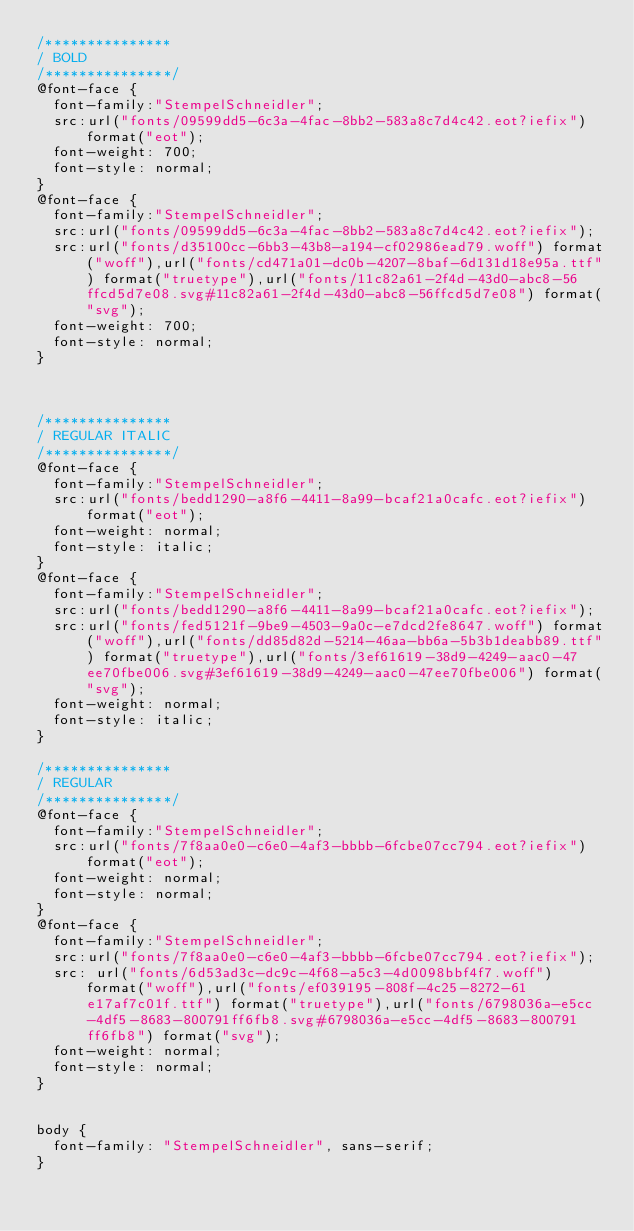Convert code to text. <code><loc_0><loc_0><loc_500><loc_500><_CSS_>/***************
/ BOLD
/***************/
@font-face {
  font-family:"StempelSchneidler";
  src:url("fonts/09599dd5-6c3a-4fac-8bb2-583a8c7d4c42.eot?iefix") format("eot");
  font-weight: 700;
  font-style: normal;
}
@font-face {
  font-family:"StempelSchneidler";
  src:url("fonts/09599dd5-6c3a-4fac-8bb2-583a8c7d4c42.eot?iefix");
  src:url("fonts/d35100cc-6bb3-43b8-a194-cf02986ead79.woff") format("woff"),url("fonts/cd471a01-dc0b-4207-8baf-6d131d18e95a.ttf") format("truetype"),url("fonts/11c82a61-2f4d-43d0-abc8-56ffcd5d7e08.svg#11c82a61-2f4d-43d0-abc8-56ffcd5d7e08") format("svg");
  font-weight: 700;
  font-style: normal;
}



/***************
/ REGULAR ITALIC
/***************/
@font-face {
  font-family:"StempelSchneidler";
  src:url("fonts/bedd1290-a8f6-4411-8a99-bcaf21a0cafc.eot?iefix") format("eot");
  font-weight: normal;
  font-style: italic;
}
@font-face {
  font-family:"StempelSchneidler";
  src:url("fonts/bedd1290-a8f6-4411-8a99-bcaf21a0cafc.eot?iefix");
  src:url("fonts/fed5121f-9be9-4503-9a0c-e7dcd2fe8647.woff") format("woff"),url("fonts/dd85d82d-5214-46aa-bb6a-5b3b1deabb89.ttf") format("truetype"),url("fonts/3ef61619-38d9-4249-aac0-47ee70fbe006.svg#3ef61619-38d9-4249-aac0-47ee70fbe006") format("svg");
  font-weight: normal;
  font-style: italic;
}

/***************
/ REGULAR
/***************/
@font-face {
  font-family:"StempelSchneidler";
  src:url("fonts/7f8aa0e0-c6e0-4af3-bbbb-6fcbe07cc794.eot?iefix") format("eot");
  font-weight: normal;
  font-style: normal;
}
@font-face {
  font-family:"StempelSchneidler";
  src:url("fonts/7f8aa0e0-c6e0-4af3-bbbb-6fcbe07cc794.eot?iefix");
  src: url("fonts/6d53ad3c-dc9c-4f68-a5c3-4d0098bbf4f7.woff") format("woff"),url("fonts/ef039195-808f-4c25-8272-61e17af7c01f.ttf") format("truetype"),url("fonts/6798036a-e5cc-4df5-8683-800791ff6fb8.svg#6798036a-e5cc-4df5-8683-800791ff6fb8") format("svg");
  font-weight: normal;
  font-style: normal;
}


body {
  font-family: "StempelSchneidler", sans-serif;
}</code> 